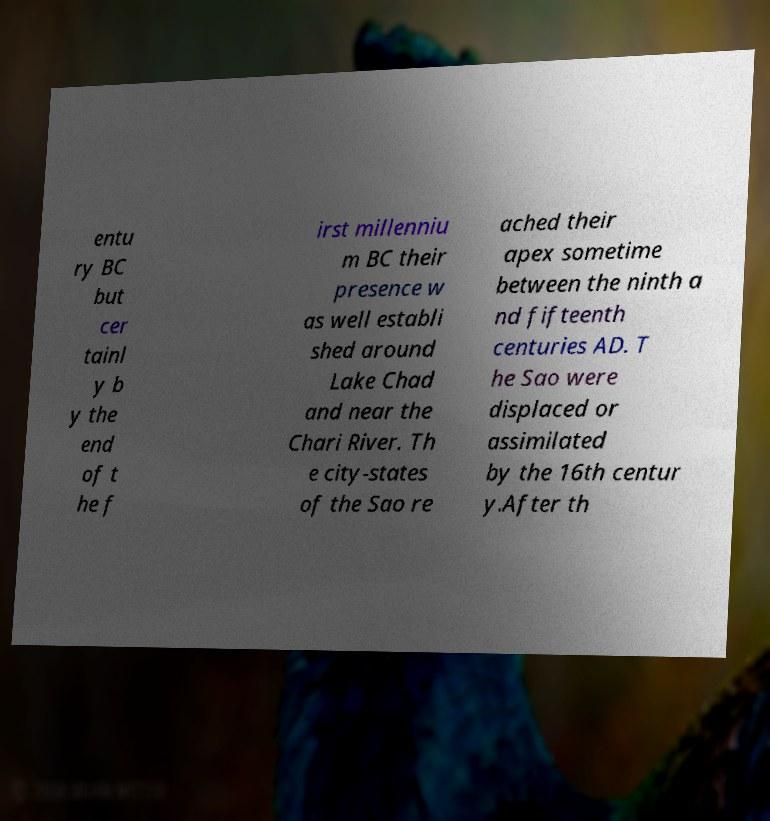Please read and relay the text visible in this image. What does it say? entu ry BC but cer tainl y b y the end of t he f irst millenniu m BC their presence w as well establi shed around Lake Chad and near the Chari River. Th e city-states of the Sao re ached their apex sometime between the ninth a nd fifteenth centuries AD. T he Sao were displaced or assimilated by the 16th centur y.After th 